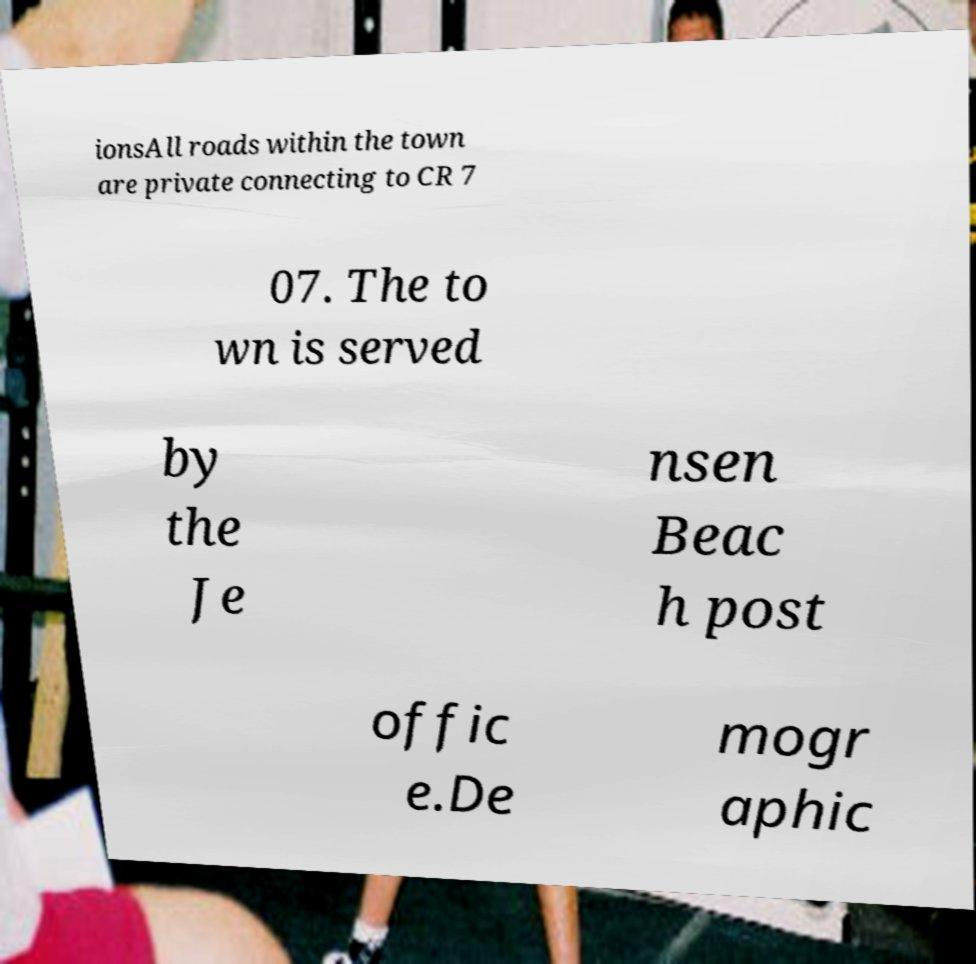Could you extract and type out the text from this image? ionsAll roads within the town are private connecting to CR 7 07. The to wn is served by the Je nsen Beac h post offic e.De mogr aphic 